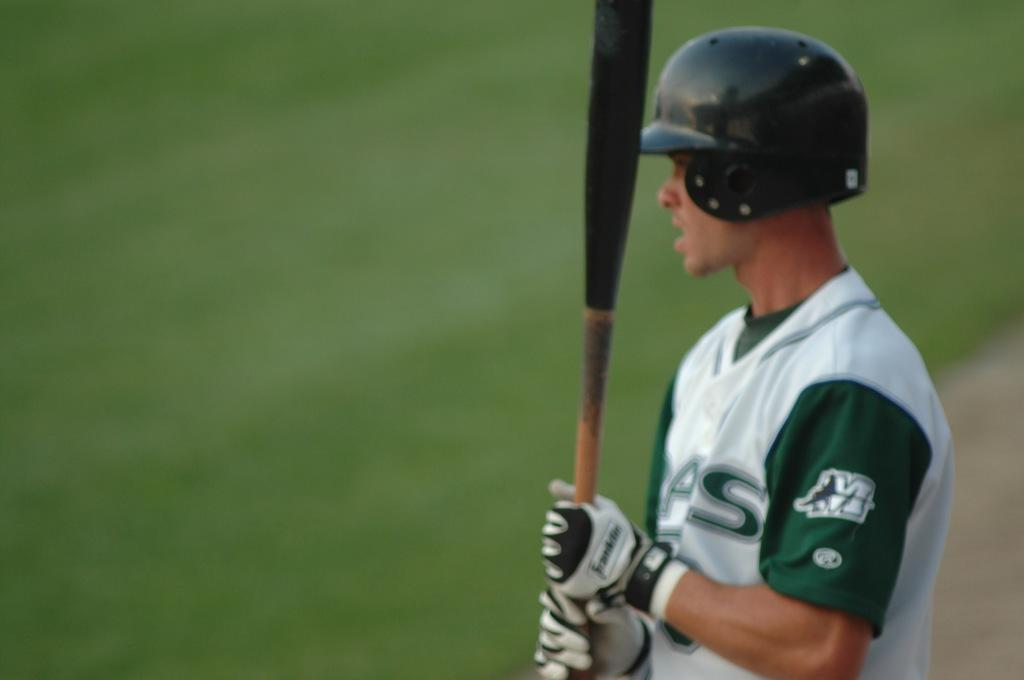Who is present in the image? There is a man in the image. What is the man wearing on his head? The man is wearing a black color helmet. What is the man wearing on his upper body? The man is wearing a white and green color T-shirt. What object is the man holding in his hands? The man is holding a bat in his hands. Can you see any dolls playing with water in the image? There are no dolls or water present in the image. Is there a squirrel visible in the image? There is no squirrel visible in the image. 